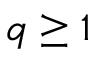<formula> <loc_0><loc_0><loc_500><loc_500>q \geq 1</formula> 